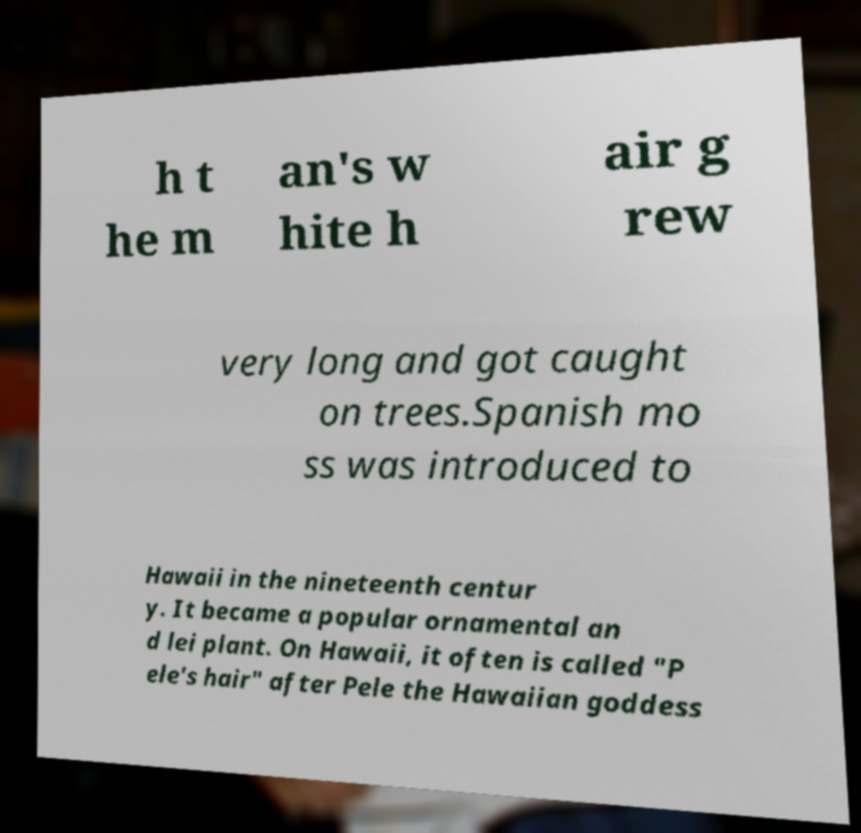Please read and relay the text visible in this image. What does it say? h t he m an's w hite h air g rew very long and got caught on trees.Spanish mo ss was introduced to Hawaii in the nineteenth centur y. It became a popular ornamental an d lei plant. On Hawaii, it often is called "P ele's hair" after Pele the Hawaiian goddess 